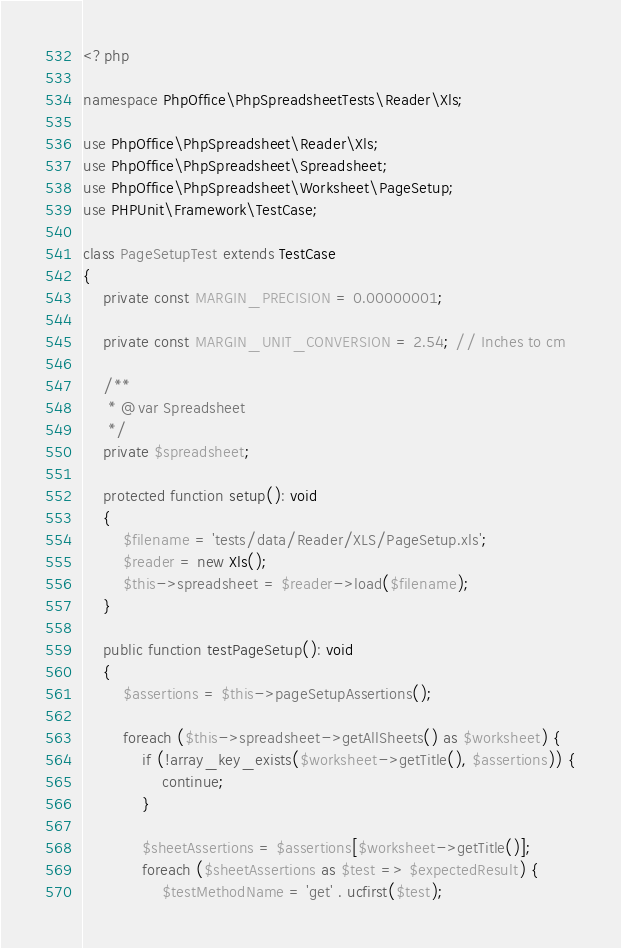<code> <loc_0><loc_0><loc_500><loc_500><_PHP_><?php

namespace PhpOffice\PhpSpreadsheetTests\Reader\Xls;

use PhpOffice\PhpSpreadsheet\Reader\Xls;
use PhpOffice\PhpSpreadsheet\Spreadsheet;
use PhpOffice\PhpSpreadsheet\Worksheet\PageSetup;
use PHPUnit\Framework\TestCase;

class PageSetupTest extends TestCase
{
    private const MARGIN_PRECISION = 0.00000001;

    private const MARGIN_UNIT_CONVERSION = 2.54; // Inches to cm

    /**
     * @var Spreadsheet
     */
    private $spreadsheet;

    protected function setup(): void
    {
        $filename = 'tests/data/Reader/XLS/PageSetup.xls';
        $reader = new Xls();
        $this->spreadsheet = $reader->load($filename);
    }

    public function testPageSetup(): void
    {
        $assertions = $this->pageSetupAssertions();

        foreach ($this->spreadsheet->getAllSheets() as $worksheet) {
            if (!array_key_exists($worksheet->getTitle(), $assertions)) {
                continue;
            }

            $sheetAssertions = $assertions[$worksheet->getTitle()];
            foreach ($sheetAssertions as $test => $expectedResult) {
                $testMethodName = 'get' . ucfirst($test);</code> 